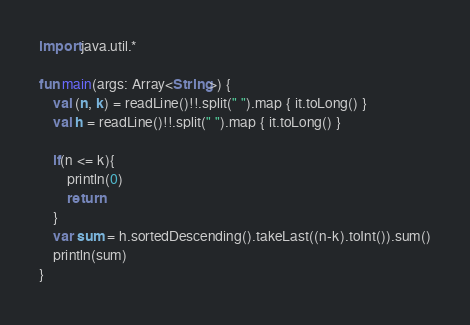<code> <loc_0><loc_0><loc_500><loc_500><_Kotlin_>import java.util.*

fun main(args: Array<String>) {
    val (n, k) = readLine()!!.split(" ").map { it.toLong() }
    val h = readLine()!!.split(" ").map { it.toLong() }

    if(n <= k){
        println(0)
        return
    }
    var sum = h.sortedDescending().takeLast((n-k).toInt()).sum()
    println(sum)
}</code> 